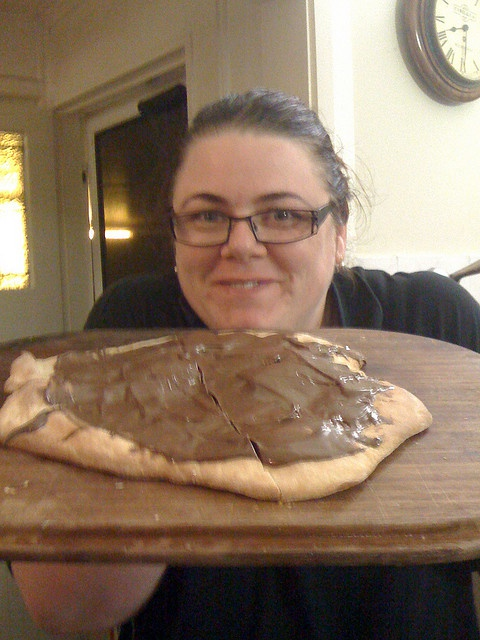Describe the objects in this image and their specific colors. I can see people in brown, black, gray, and maroon tones, pizza in brown, gray, and tan tones, and clock in brown, beige, gray, and darkgray tones in this image. 